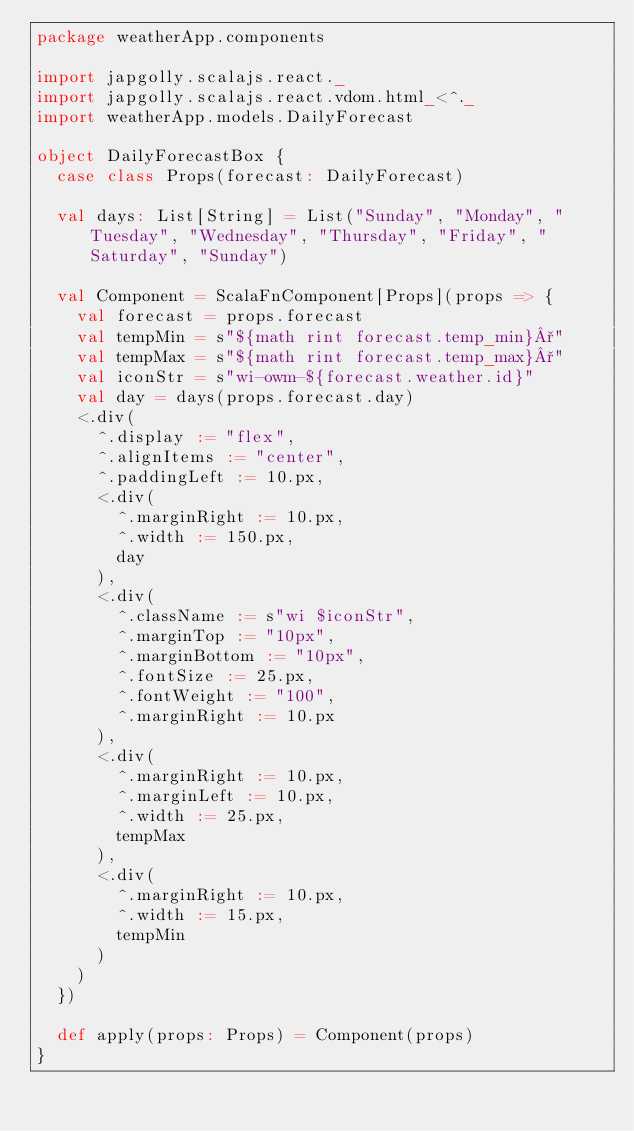Convert code to text. <code><loc_0><loc_0><loc_500><loc_500><_Scala_>package weatherApp.components

import japgolly.scalajs.react._
import japgolly.scalajs.react.vdom.html_<^._
import weatherApp.models.DailyForecast

object DailyForecastBox {
  case class Props(forecast: DailyForecast)

  val days: List[String] = List("Sunday", "Monday", "Tuesday", "Wednesday", "Thursday", "Friday", "Saturday", "Sunday")

  val Component = ScalaFnComponent[Props](props => {
    val forecast = props.forecast
    val tempMin = s"${math rint forecast.temp_min}°"
    val tempMax = s"${math rint forecast.temp_max}°"
    val iconStr = s"wi-owm-${forecast.weather.id}"
    val day = days(props.forecast.day)
    <.div(
      ^.display := "flex",
      ^.alignItems := "center",
      ^.paddingLeft := 10.px,
      <.div(
        ^.marginRight := 10.px,
        ^.width := 150.px,
        day
      ),
      <.div(
        ^.className := s"wi $iconStr",
        ^.marginTop := "10px",
        ^.marginBottom := "10px",
        ^.fontSize := 25.px,
        ^.fontWeight := "100",
        ^.marginRight := 10.px
      ),
      <.div(
        ^.marginRight := 10.px,
        ^.marginLeft := 10.px,
        ^.width := 25.px,
        tempMax
      ),
      <.div(
        ^.marginRight := 10.px,
        ^.width := 15.px,
        tempMin
      )
    )
  })

  def apply(props: Props) = Component(props)
}
</code> 